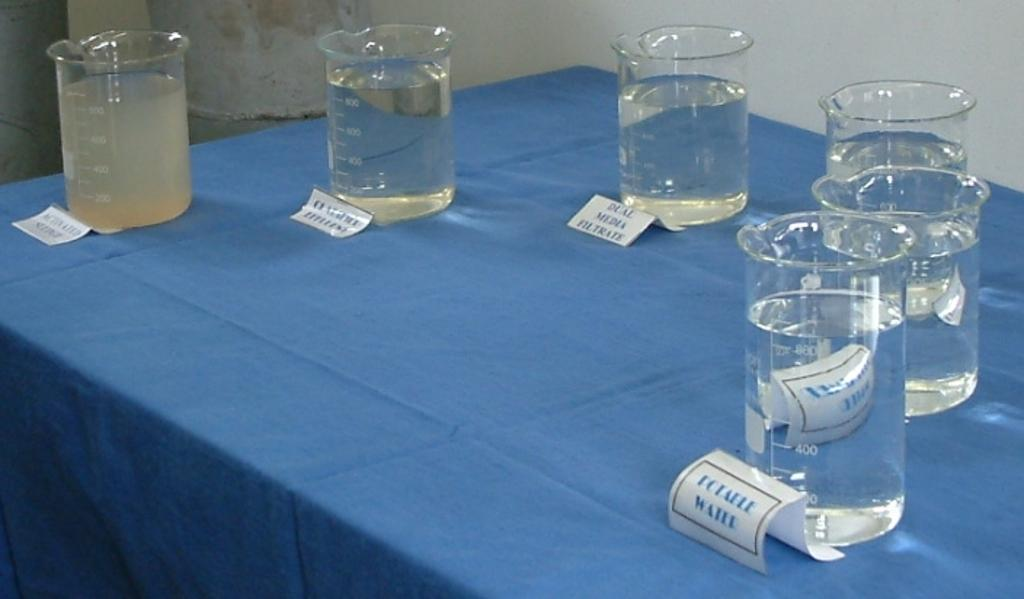<image>
Summarize the visual content of the image. Cups of liquids placed on a table with one called "Potaele Water". 